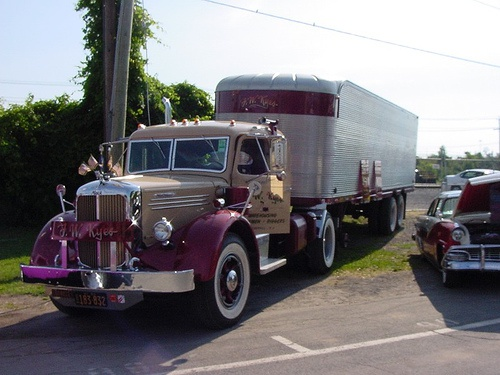Describe the objects in this image and their specific colors. I can see truck in lavender, black, gray, and darkgray tones, car in lavender, black, gray, maroon, and darkgray tones, and car in lavender, darkgray, and gray tones in this image. 